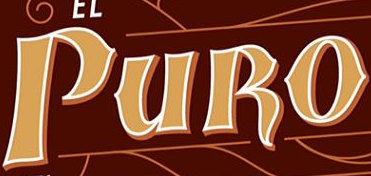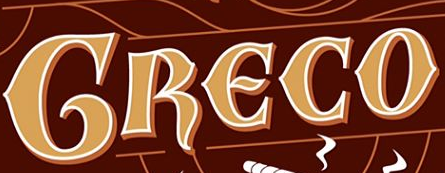What text is displayed in these images sequentially, separated by a semicolon? PURO; GRECO 